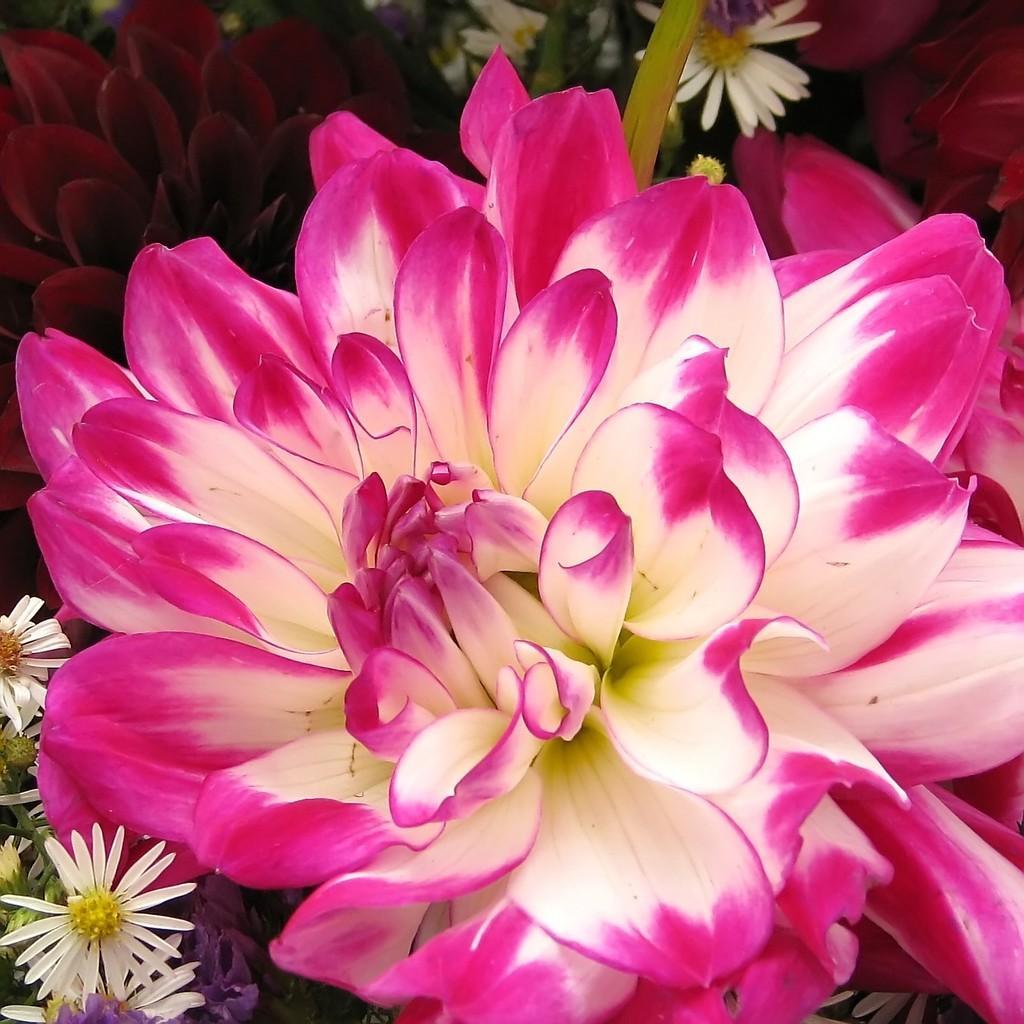Please provide a concise description of this image. In this image we can see there are some flowers. 